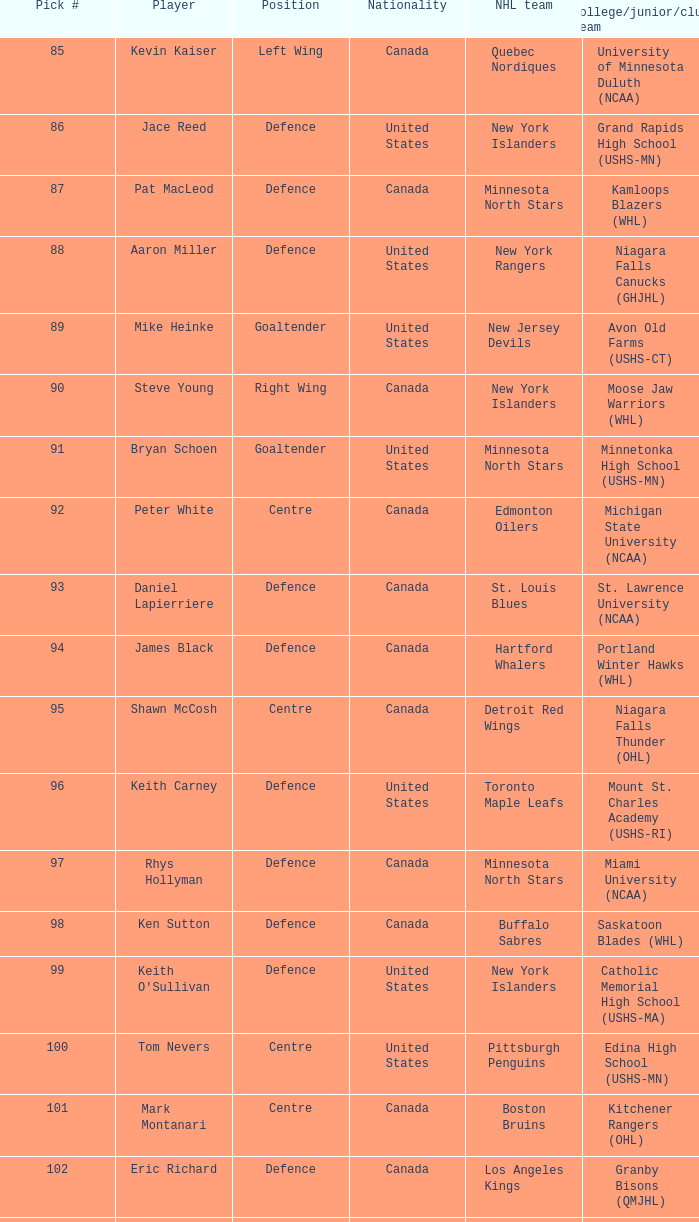What country does keith carney come from? United States. 